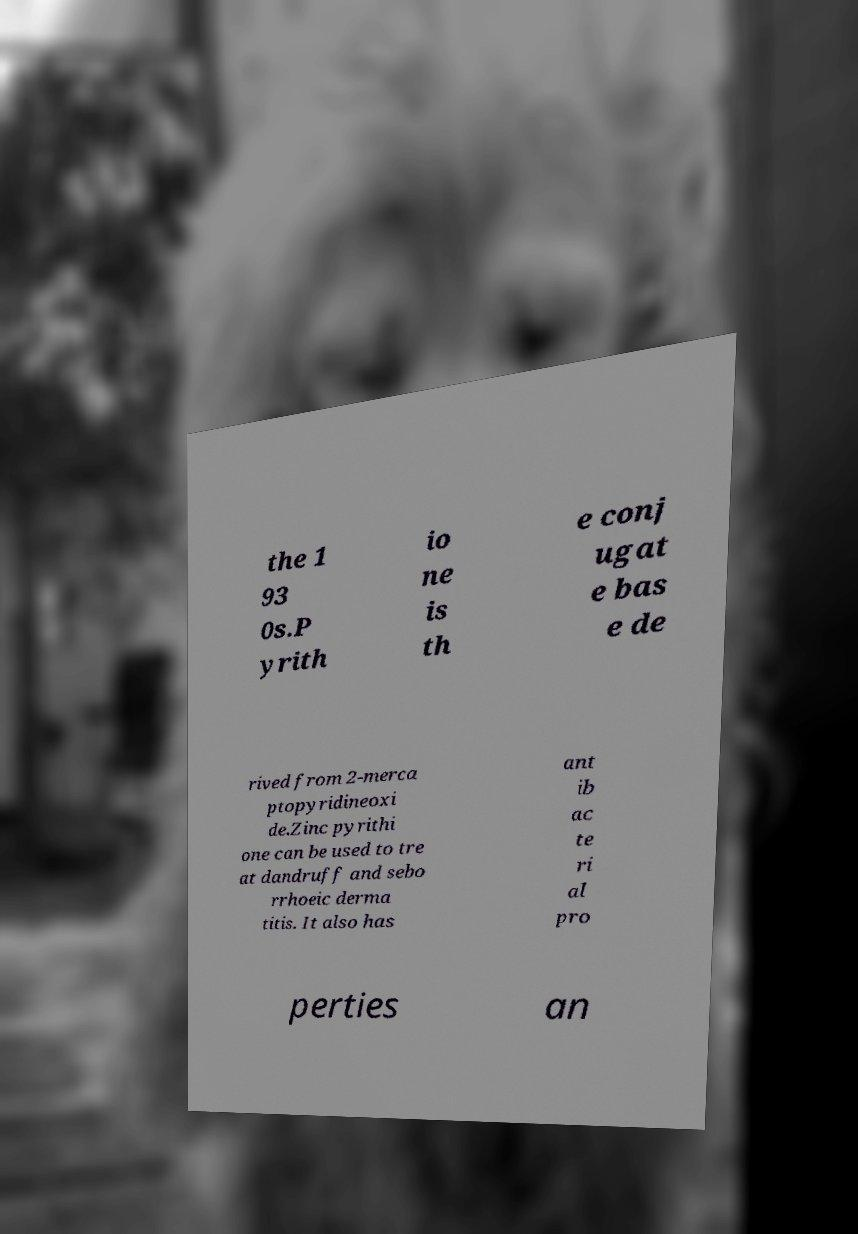For documentation purposes, I need the text within this image transcribed. Could you provide that? the 1 93 0s.P yrith io ne is th e conj ugat e bas e de rived from 2-merca ptopyridineoxi de.Zinc pyrithi one can be used to tre at dandruff and sebo rrhoeic derma titis. It also has ant ib ac te ri al pro perties an 